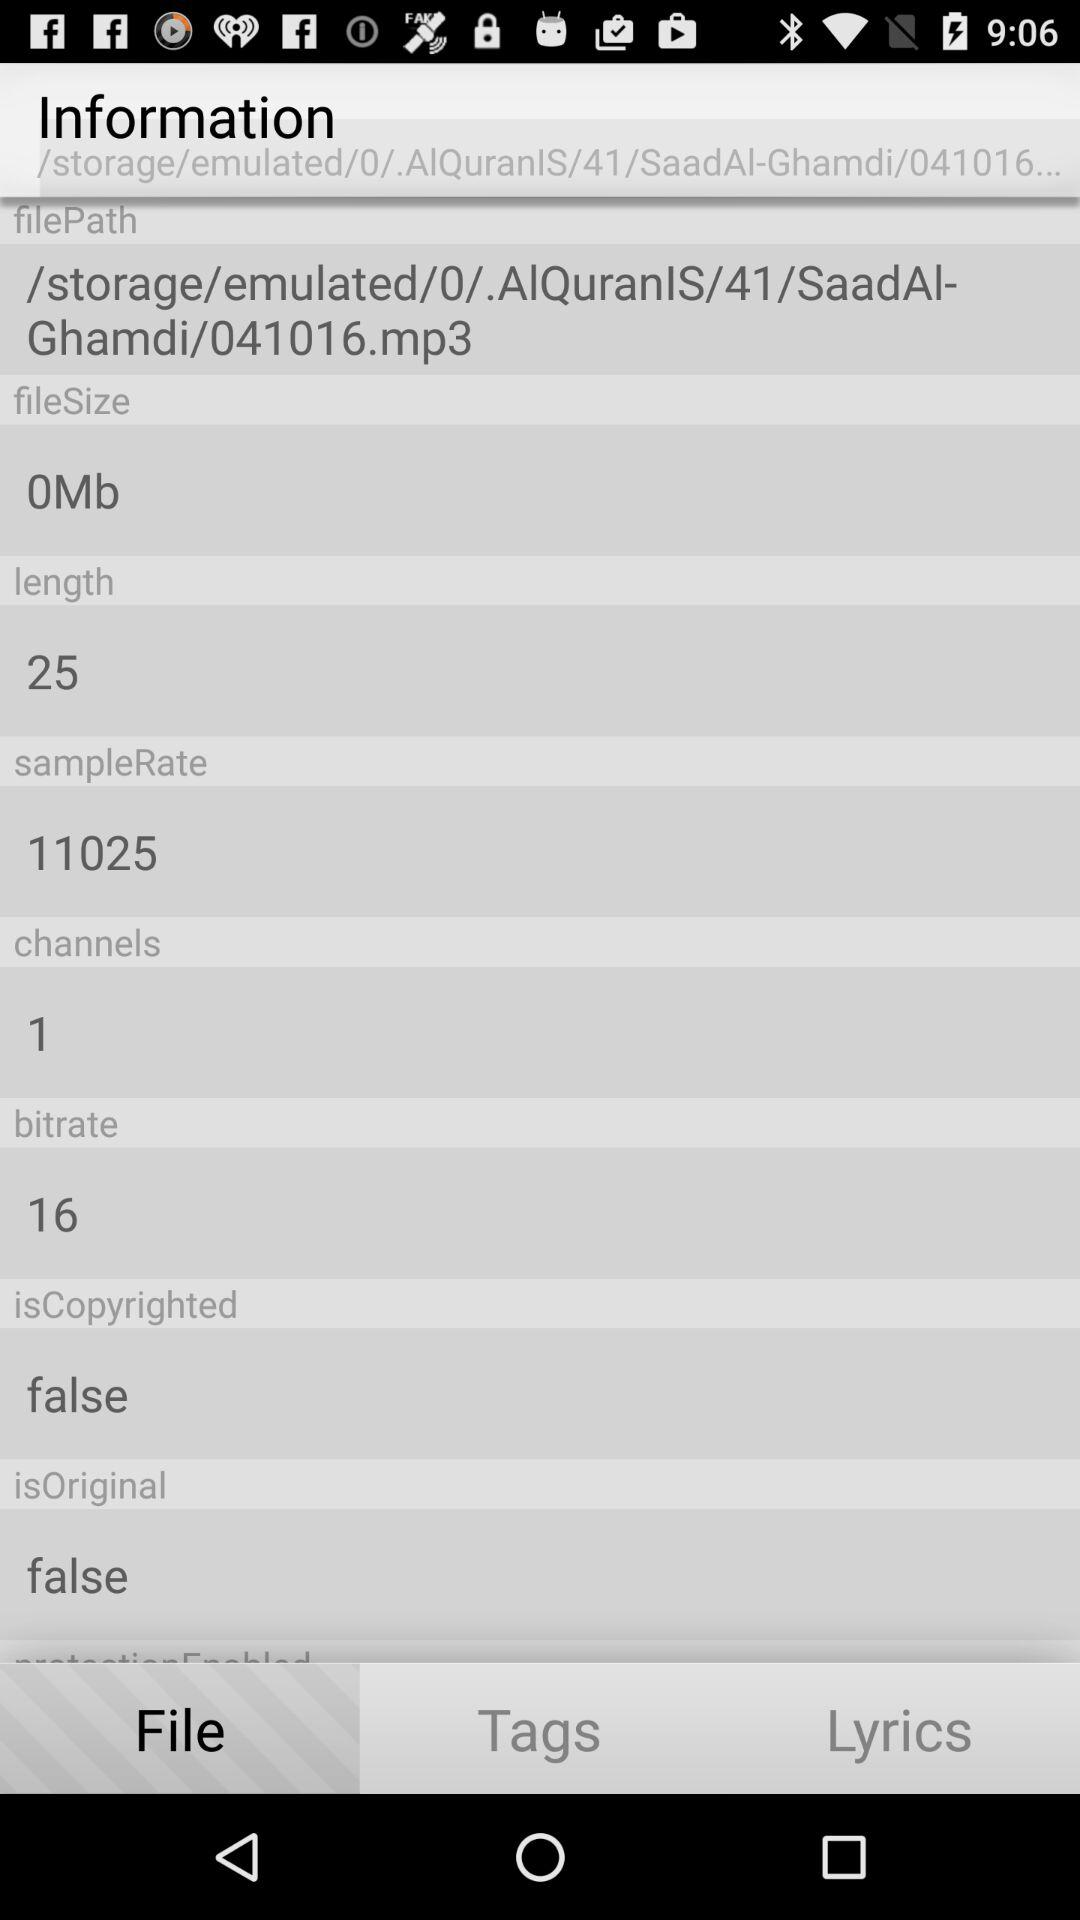What is the sample rate? The sample rate is 11025. 